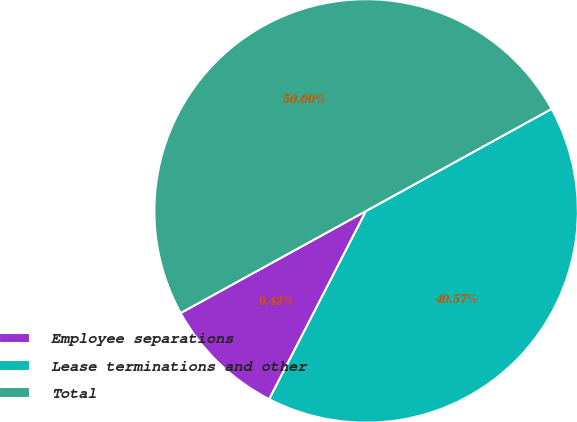Convert chart to OTSL. <chart><loc_0><loc_0><loc_500><loc_500><pie_chart><fcel>Employee separations<fcel>Lease terminations and other<fcel>Total<nl><fcel>9.43%<fcel>40.57%<fcel>50.0%<nl></chart> 